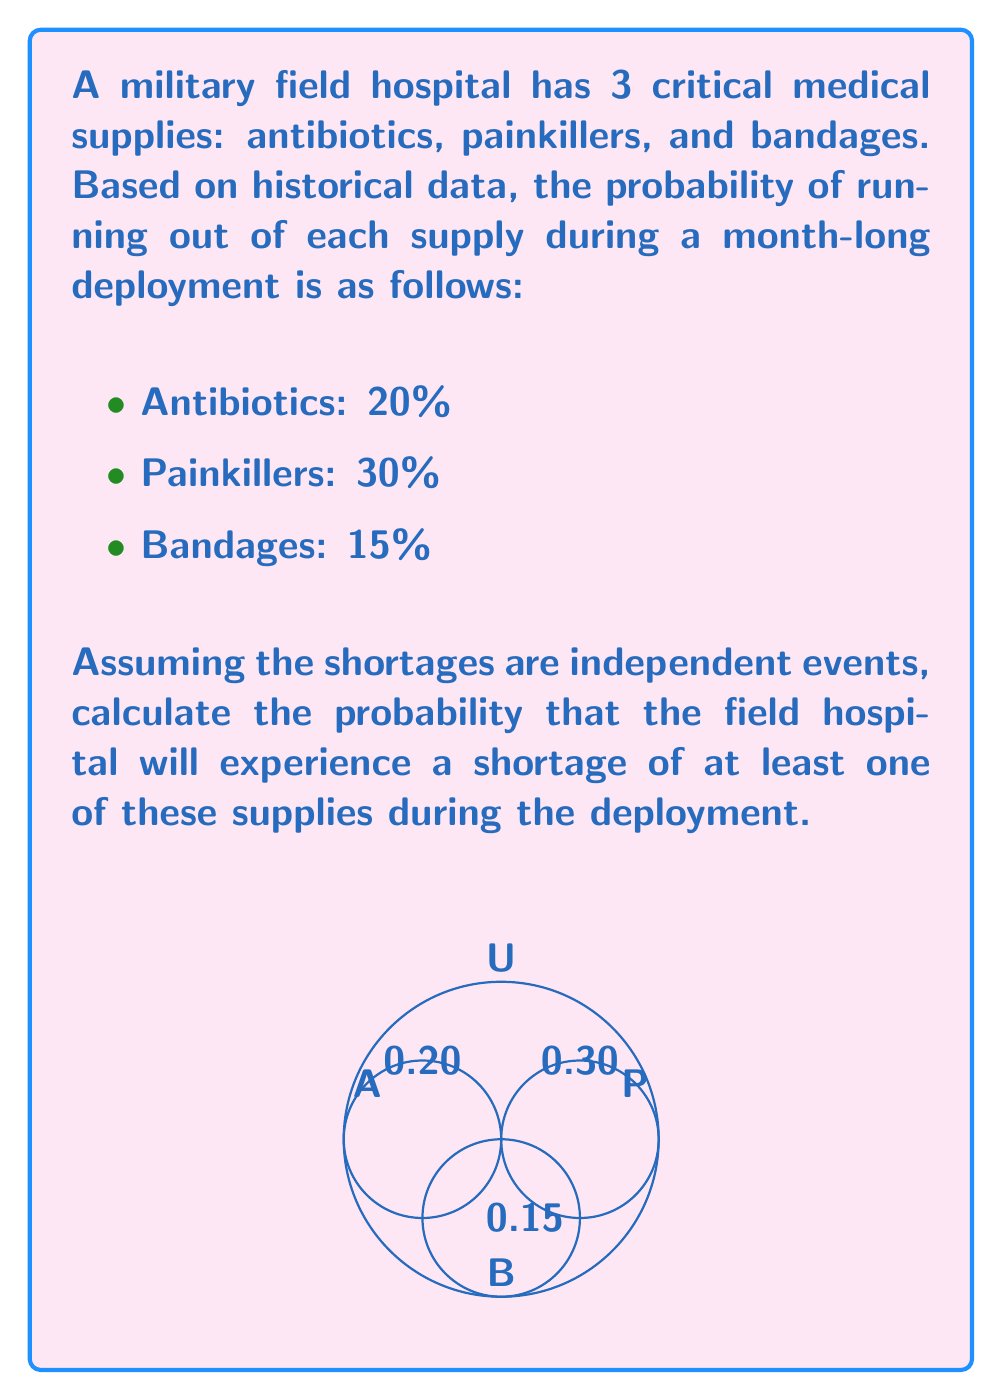Help me with this question. Let's approach this step-by-step using the concept of probability of the complement event:

1) Let A be the event of antibiotic shortage, P be painkiller shortage, and B be bandage shortage.

2) We want to find P(at least one shortage) = 1 - P(no shortages)

3) P(no shortages) = P(no A AND no P AND no B)

4) Since the events are independent:
   P(no shortages) = P(no A) × P(no P) × P(no B)

5) P(no A) = 1 - P(A) = 1 - 0.20 = 0.80
   P(no P) = 1 - P(P) = 1 - 0.30 = 0.70
   P(no B) = 1 - P(B) = 1 - 0.15 = 0.85

6) P(no shortages) = 0.80 × 0.70 × 0.85 = 0.476

7) Therefore, P(at least one shortage) = 1 - 0.476 = 0.524

8) Convert to percentage: 0.524 × 100% = 52.4%
Answer: 52.4% 